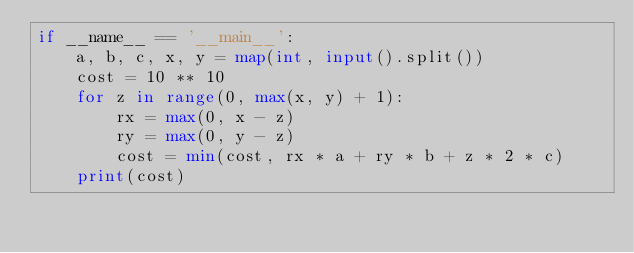<code> <loc_0><loc_0><loc_500><loc_500><_Python_>if __name__ == '__main__':
    a, b, c, x, y = map(int, input().split())
    cost = 10 ** 10
    for z in range(0, max(x, y) + 1):
        rx = max(0, x - z)
        ry = max(0, y - z)
        cost = min(cost, rx * a + ry * b + z * 2 * c)
    print(cost)</code> 